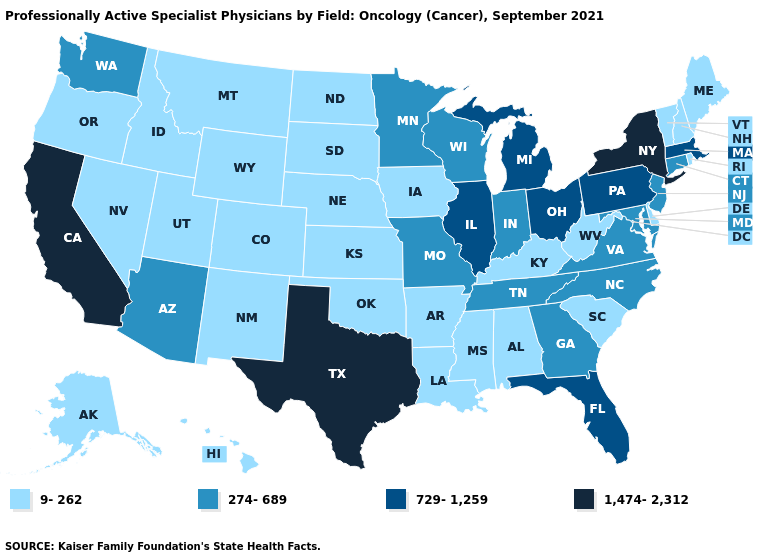How many symbols are there in the legend?
Write a very short answer. 4. Does Vermont have the highest value in the USA?
Write a very short answer. No. Among the states that border Kentucky , does Virginia have the highest value?
Short answer required. No. What is the value of Colorado?
Concise answer only. 9-262. What is the lowest value in states that border Nebraska?
Quick response, please. 9-262. Is the legend a continuous bar?
Be succinct. No. Does the map have missing data?
Keep it brief. No. Name the states that have a value in the range 1,474-2,312?
Keep it brief. California, New York, Texas. Name the states that have a value in the range 274-689?
Quick response, please. Arizona, Connecticut, Georgia, Indiana, Maryland, Minnesota, Missouri, New Jersey, North Carolina, Tennessee, Virginia, Washington, Wisconsin. What is the value of New York?
Short answer required. 1,474-2,312. Does Texas have the lowest value in the South?
Short answer required. No. Name the states that have a value in the range 1,474-2,312?
Be succinct. California, New York, Texas. Does Missouri have the lowest value in the USA?
Be succinct. No. Name the states that have a value in the range 9-262?
Quick response, please. Alabama, Alaska, Arkansas, Colorado, Delaware, Hawaii, Idaho, Iowa, Kansas, Kentucky, Louisiana, Maine, Mississippi, Montana, Nebraska, Nevada, New Hampshire, New Mexico, North Dakota, Oklahoma, Oregon, Rhode Island, South Carolina, South Dakota, Utah, Vermont, West Virginia, Wyoming. 